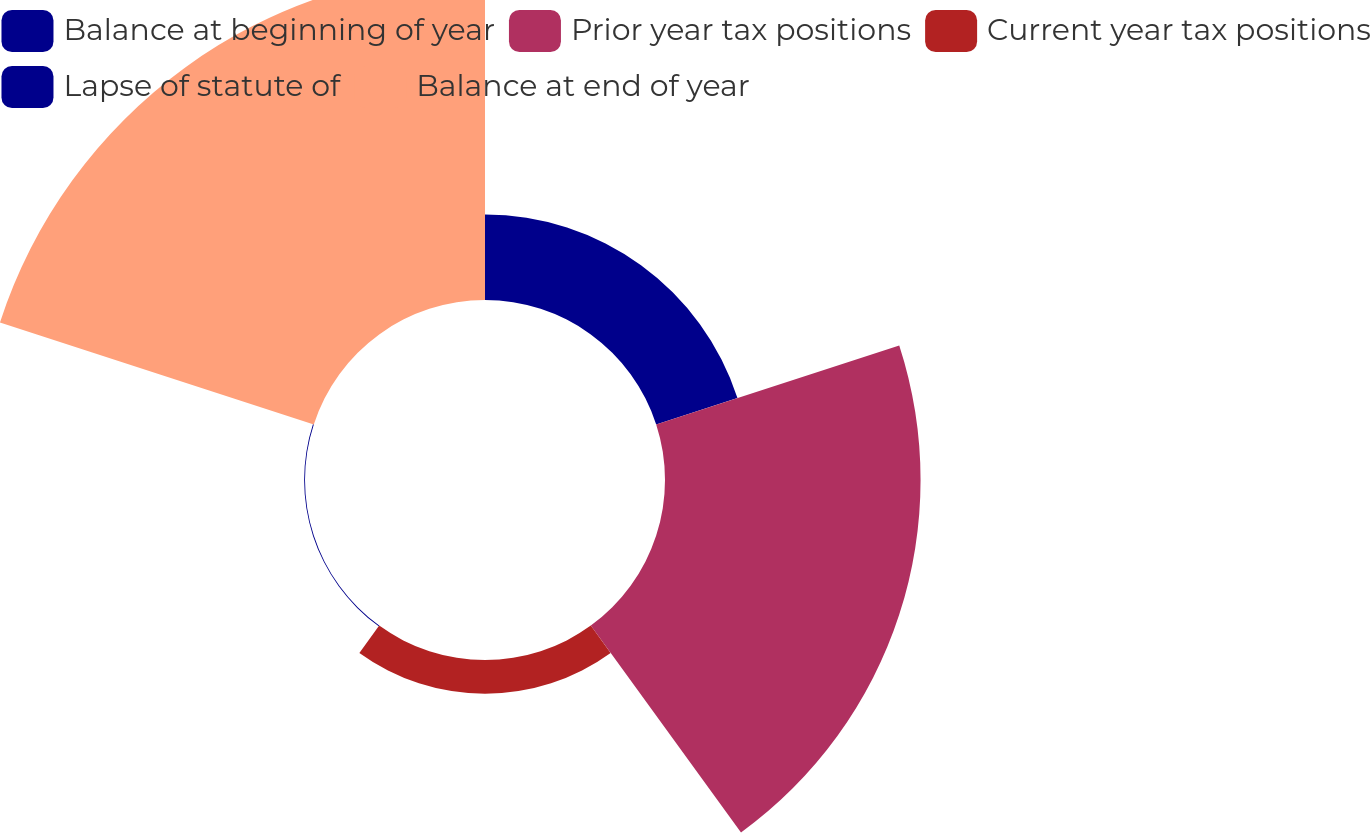Convert chart to OTSL. <chart><loc_0><loc_0><loc_500><loc_500><pie_chart><fcel>Balance at beginning of year<fcel>Prior year tax positions<fcel>Current year tax positions<fcel>Lapse of statute of<fcel>Balance at end of year<nl><fcel>12.11%<fcel>36.22%<fcel>4.78%<fcel>0.12%<fcel>46.77%<nl></chart> 